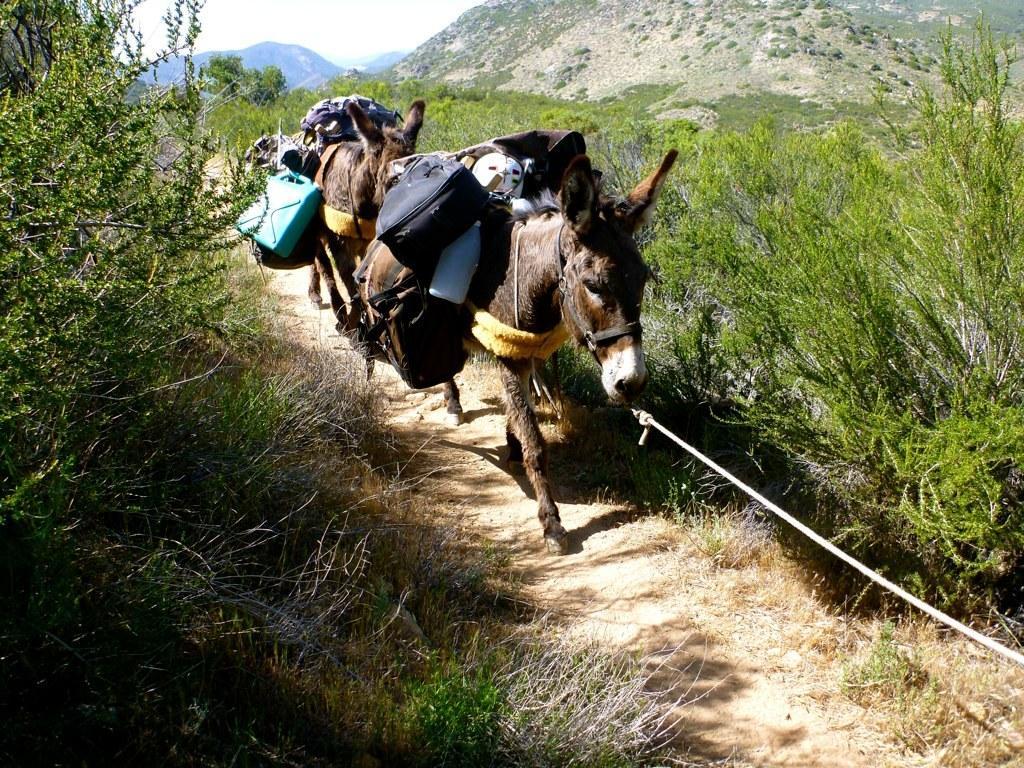Can you describe this image briefly? In this image there are two donkeys, on either side of the donkeys there are plants, in the background there is a mountain. 